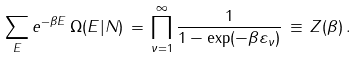<formula> <loc_0><loc_0><loc_500><loc_500>\sum _ { E } e ^ { - \beta E } \, \Omega ( E | N ) \, = \, \prod _ { \nu = 1 } ^ { \infty } \frac { 1 } { 1 - \exp ( - \beta \varepsilon _ { \nu } ) } \, \equiv \, Z ( \beta ) \, .</formula> 